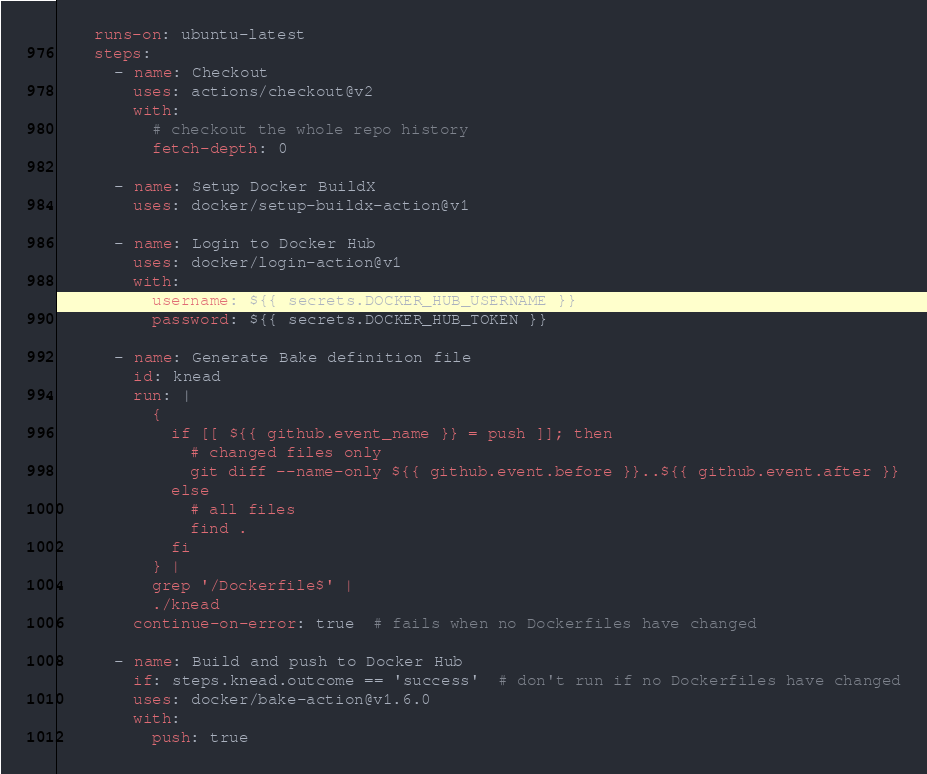<code> <loc_0><loc_0><loc_500><loc_500><_YAML_>    runs-on: ubuntu-latest
    steps:
      - name: Checkout
        uses: actions/checkout@v2
        with:
          # checkout the whole repo history
          fetch-depth: 0

      - name: Setup Docker BuildX
        uses: docker/setup-buildx-action@v1

      - name: Login to Docker Hub
        uses: docker/login-action@v1
        with:
          username: ${{ secrets.DOCKER_HUB_USERNAME }}
          password: ${{ secrets.DOCKER_HUB_TOKEN }}

      - name: Generate Bake definition file
        id: knead
        run: |
          {
            if [[ ${{ github.event_name }} = push ]]; then
              # changed files only
              git diff --name-only ${{ github.event.before }}..${{ github.event.after }}
            else
              # all files
              find .
            fi
          } |
          grep '/Dockerfile$' |
          ./knead
        continue-on-error: true  # fails when no Dockerfiles have changed

      - name: Build and push to Docker Hub
        if: steps.knead.outcome == 'success'  # don't run if no Dockerfiles have changed
        uses: docker/bake-action@v1.6.0
        with:
          push: true
</code> 